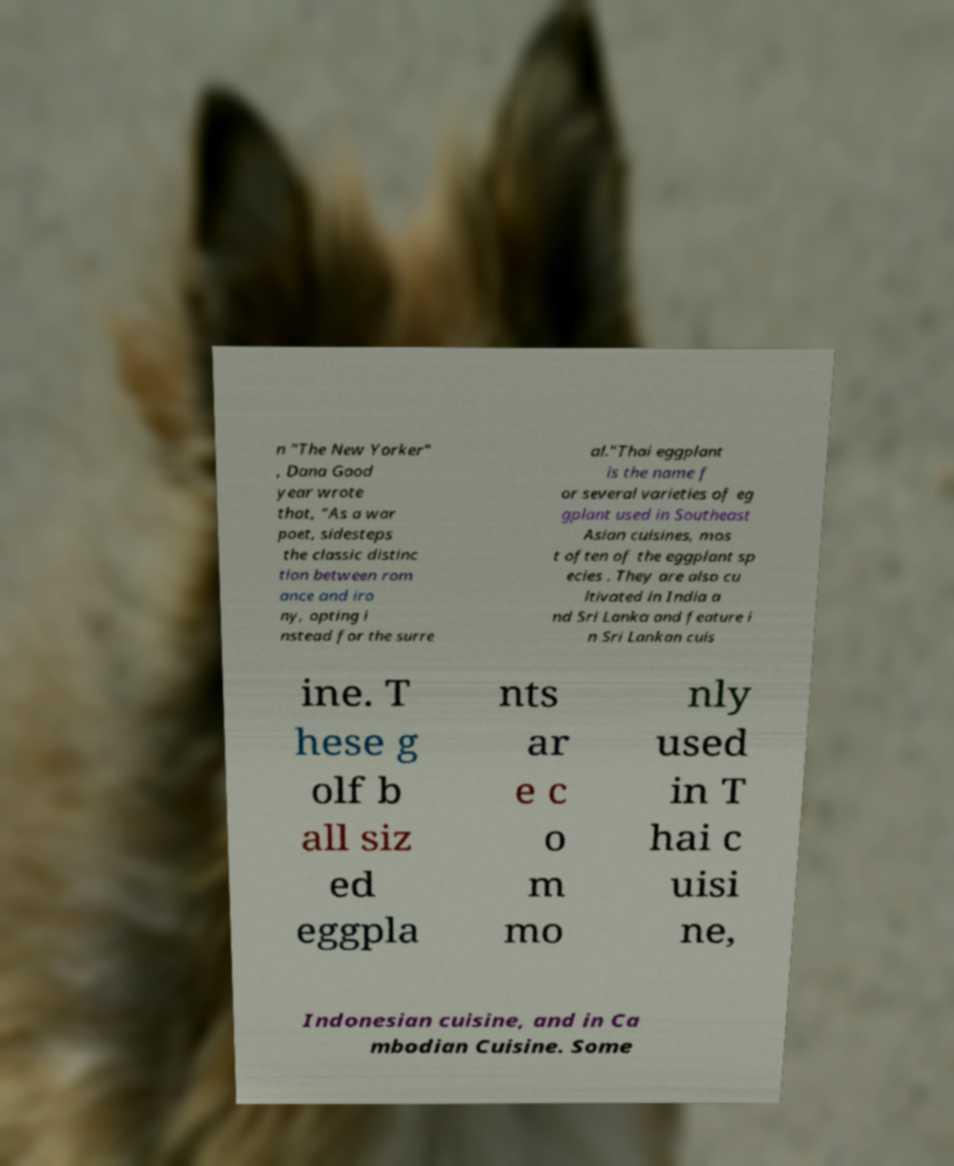For documentation purposes, I need the text within this image transcribed. Could you provide that? n "The New Yorker" , Dana Good year wrote that, "As a war poet, sidesteps the classic distinc tion between rom ance and iro ny, opting i nstead for the surre al."Thai eggplant is the name f or several varieties of eg gplant used in Southeast Asian cuisines, mos t often of the eggplant sp ecies . They are also cu ltivated in India a nd Sri Lanka and feature i n Sri Lankan cuis ine. T hese g olf b all siz ed eggpla nts ar e c o m mo nly used in T hai c uisi ne, Indonesian cuisine, and in Ca mbodian Cuisine. Some 